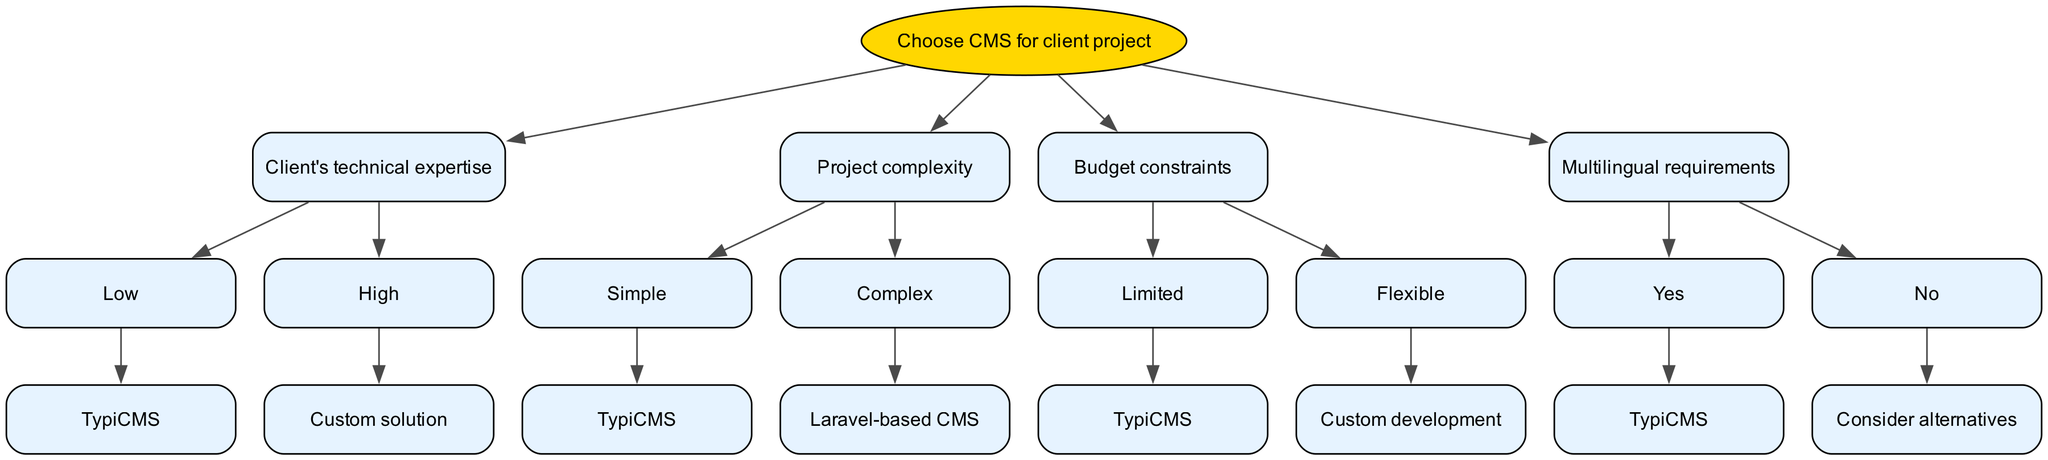What is the root node of the decision tree? The root node is the starting point of the decision tree. In this case, it is labeled "Choose CMS for client project."
Answer: Choose CMS for client project How many main decision nodes are in the diagram? The diagram has four main decision nodes which are based on different criteria: technical expertise, project complexity, budget constraints, and multilingual requirements.
Answer: 4 What CMS is recommended for clients with low technical expertise? According to the decision tree, clients with low technical expertise are recommended to use TypiCMS.
Answer: TypiCMS What CMS option is suggested for complex projects? The diagram indicates that if the project is complex, the suggested CMS is a Laravel-based CMS.
Answer: Laravel-based CMS If a client has a flexible budget and needs multilingual support, which CMS should they choose? To find the answer, we follow the budget constraint to the "Flexible" path and then check the multilingual requirement. Since multilingual support is needed, TypiCMS will be the final recommendation, as it meets both criteria.
Answer: TypiCMS Which decision leads to a consideration of alternatives in the CMS selection? The path that leads to considering alternatives is when the multilingual requirements are "No." This decision point directly suggests to consider other CMS options.
Answer: No What is the suggested CMS if the project is simple and the client has limited budget? In this scenario, we follow the path for both simple project and limited budget, which leads directly to TypiCMS as the recommended option.
Answer: TypiCMS How do budget constraints affect the choice of CMS? The decision tree shows that budget constraints influence the choice by classifying it into "Limited" or "Flexible." A limited budget leads to TypiCMS while a flexible budget opens up options for custom development. Therefore, it indicates a significant impact of budget on the selection.
Answer: Limited or Flexible What will be the CMS recommendation if a client needs a custom solution? The recommendation for a custom solution only arises from the "High" technical expertise path. Therefore, the answer will be "Custom solution."
Answer: Custom solution 